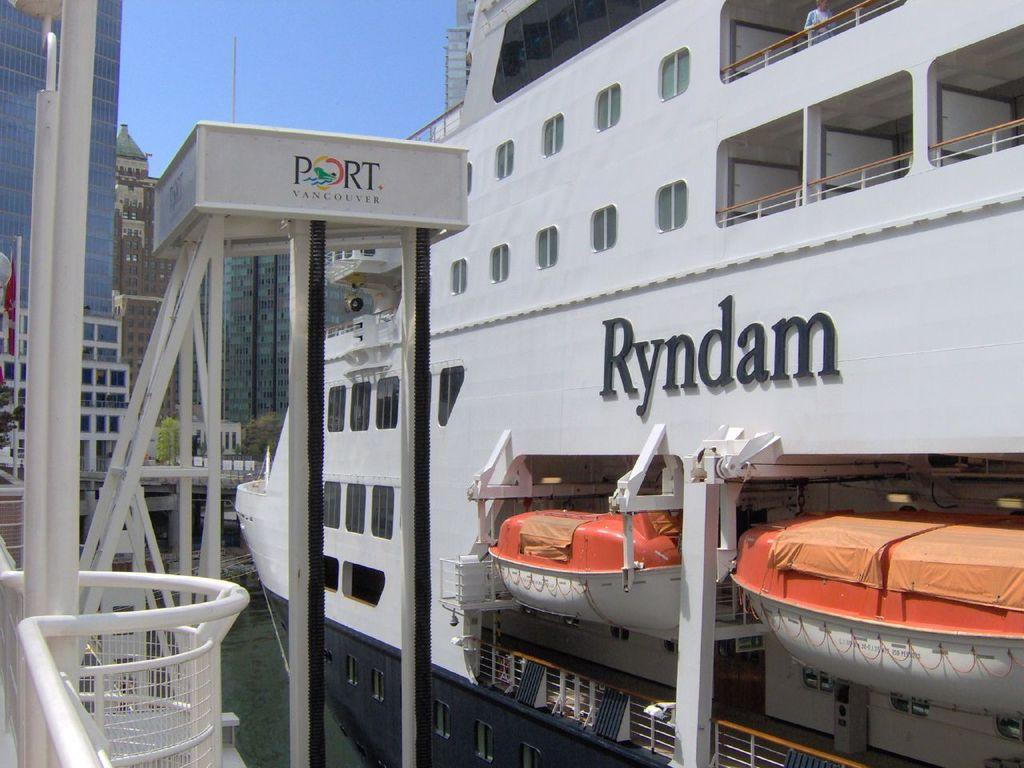Provide a one-sentence caption for the provided image. A cruise ship in a port that reads Ryndam. 